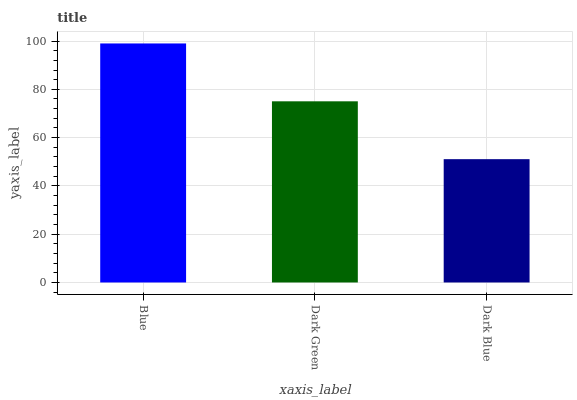Is Dark Blue the minimum?
Answer yes or no. Yes. Is Blue the maximum?
Answer yes or no. Yes. Is Dark Green the minimum?
Answer yes or no. No. Is Dark Green the maximum?
Answer yes or no. No. Is Blue greater than Dark Green?
Answer yes or no. Yes. Is Dark Green less than Blue?
Answer yes or no. Yes. Is Dark Green greater than Blue?
Answer yes or no. No. Is Blue less than Dark Green?
Answer yes or no. No. Is Dark Green the high median?
Answer yes or no. Yes. Is Dark Green the low median?
Answer yes or no. Yes. Is Blue the high median?
Answer yes or no. No. Is Blue the low median?
Answer yes or no. No. 